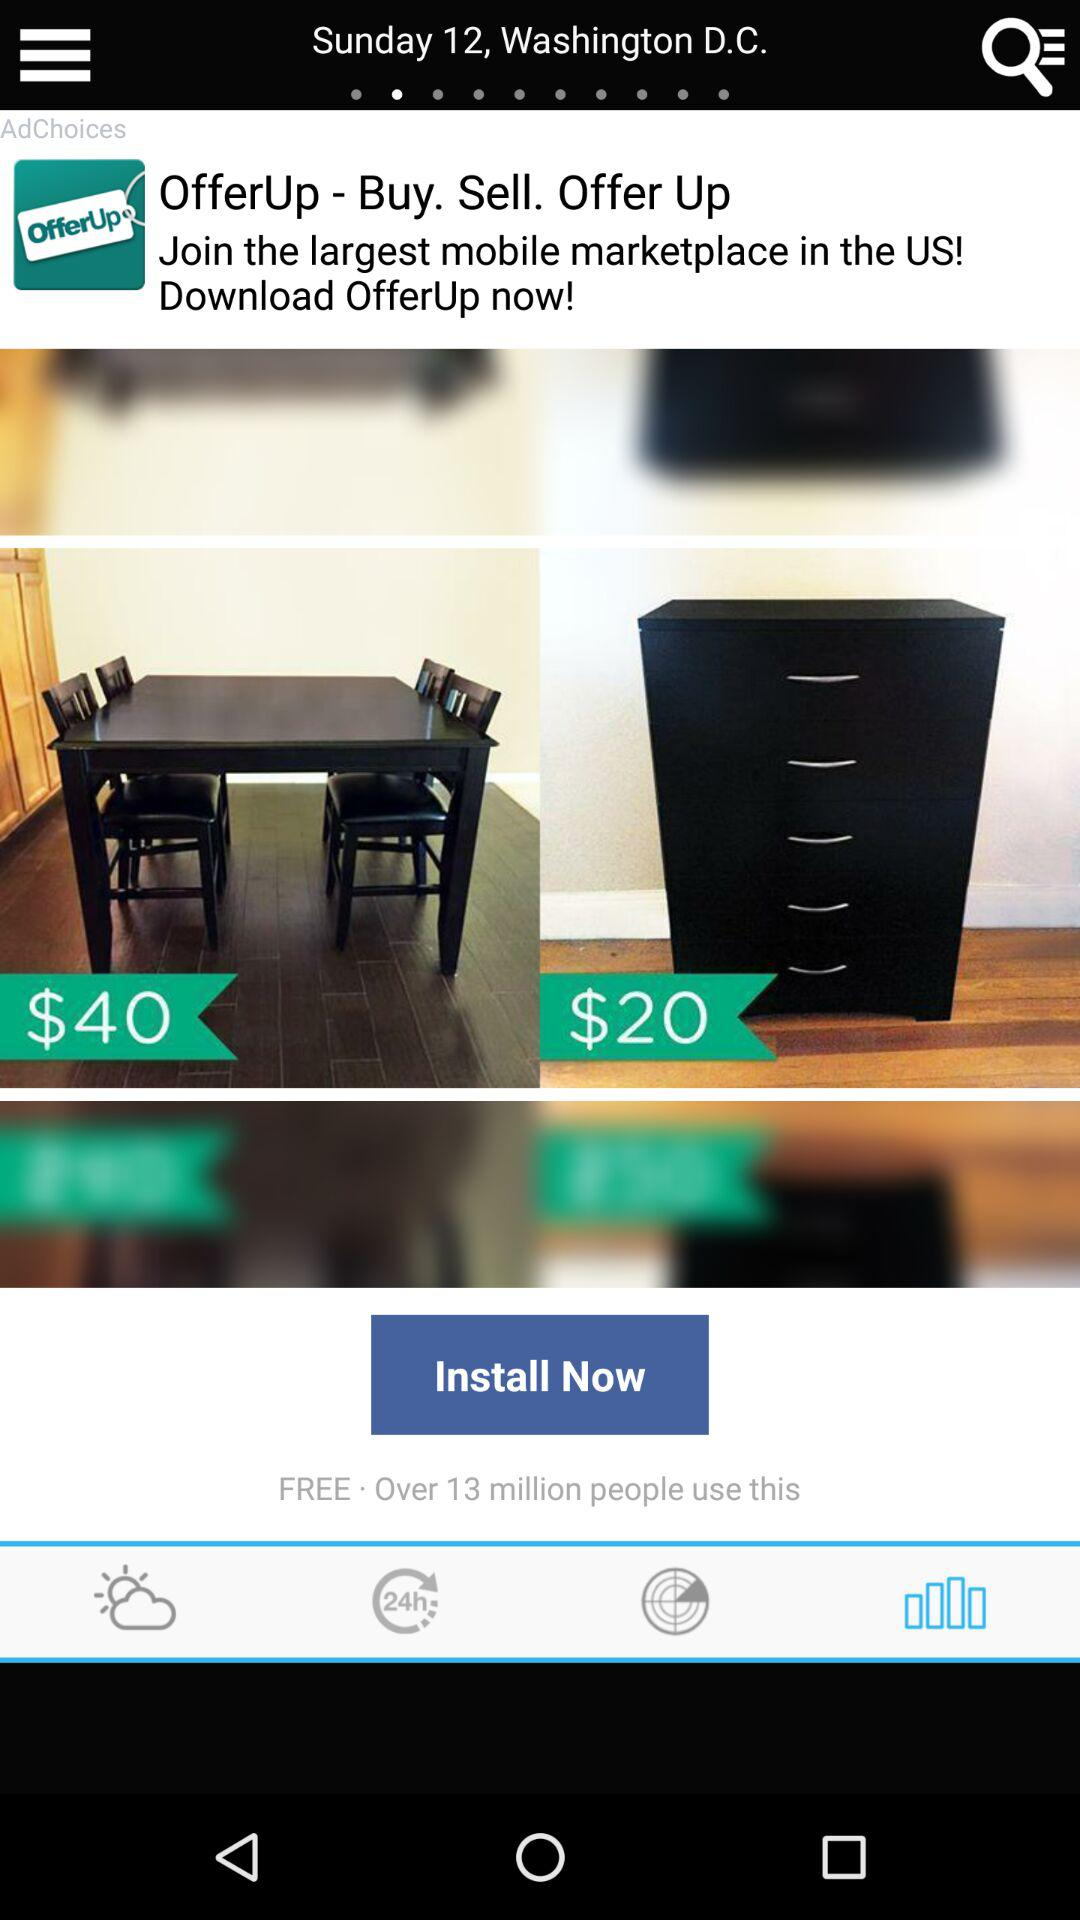How much does the furniture cost? The furniture costs $40 and $20. 